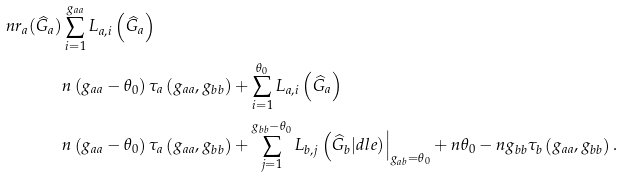Convert formula to latex. <formula><loc_0><loc_0><loc_500><loc_500>n r _ { a } ( \widehat { G } _ { a } ) & \sum _ { i = 1 } ^ { g _ { a a } } L _ { a , i } \left ( \widehat { G } _ { a } \right ) \\ & n \left ( g _ { a a } - \theta _ { 0 } \right ) \tau _ { a } \left ( g _ { a a } , g _ { b b } \right ) + \sum _ { i = 1 } ^ { \theta _ { 0 } } L _ { a , i } \left ( \widehat { G } _ { a } \right ) \\ & n \left ( g _ { a a } - \theta _ { 0 } \right ) \tau _ { a } \left ( g _ { a a } , g _ { b b } \right ) + \sum _ { j = 1 } ^ { g _ { b b } - \theta _ { 0 } } L _ { b , j } \left ( \widehat { G } _ { b } | d l e ) \right | _ { g _ { a b } = \theta _ { 0 } } + n \theta _ { 0 } - n g _ { b b } \tau _ { b } \left ( g _ { a a } , g _ { b b } \right ) .</formula> 